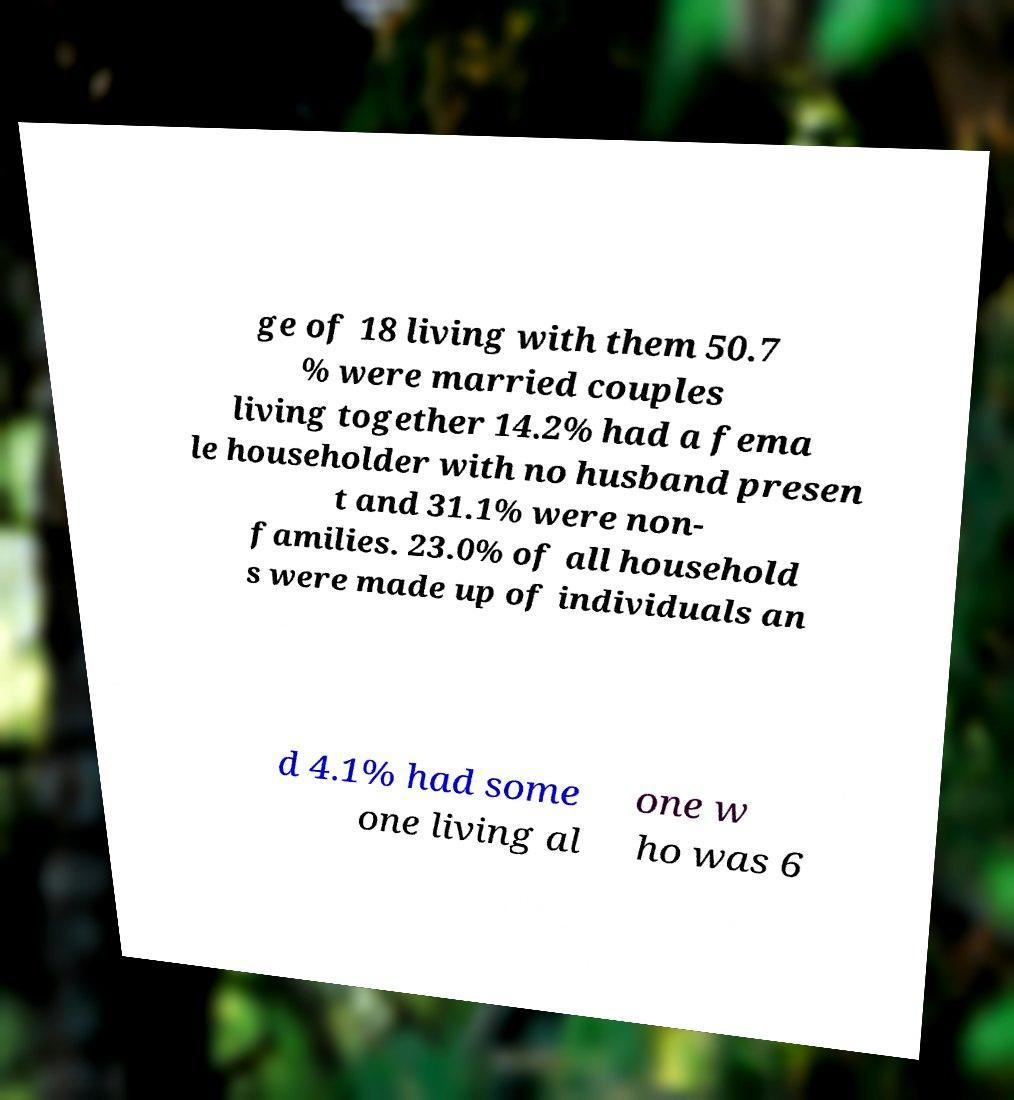I need the written content from this picture converted into text. Can you do that? ge of 18 living with them 50.7 % were married couples living together 14.2% had a fema le householder with no husband presen t and 31.1% were non- families. 23.0% of all household s were made up of individuals an d 4.1% had some one living al one w ho was 6 